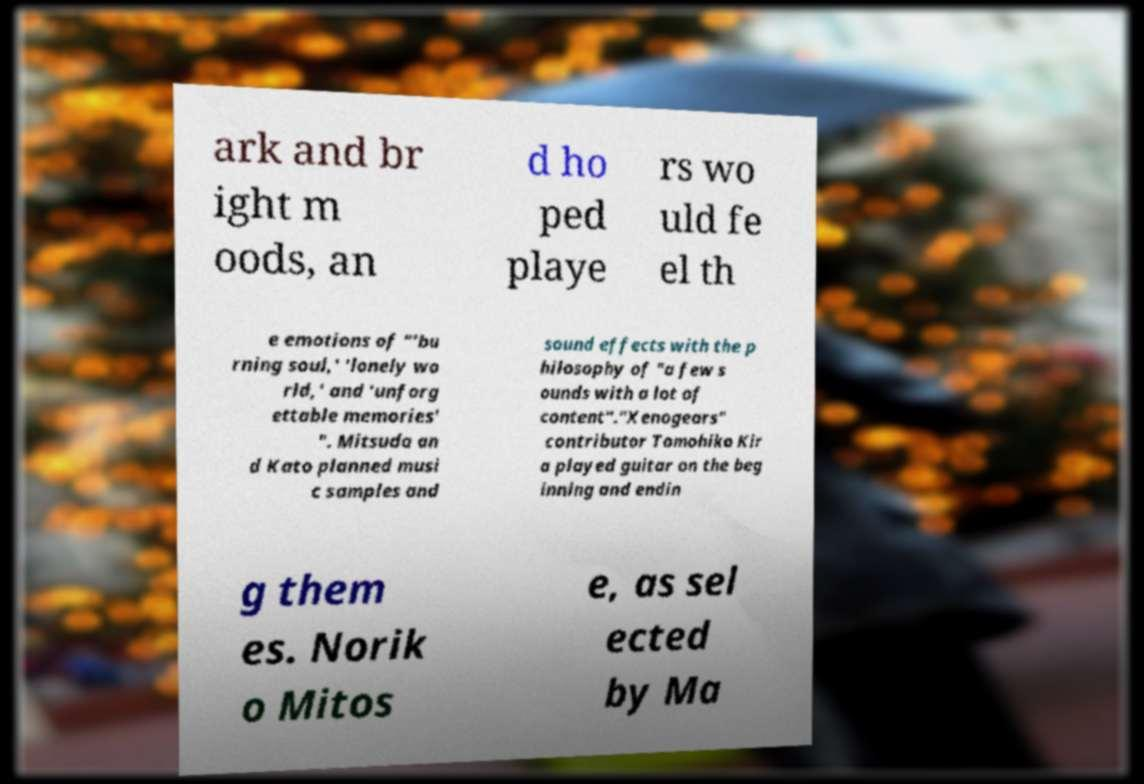For documentation purposes, I need the text within this image transcribed. Could you provide that? ark and br ight m oods, an d ho ped playe rs wo uld fe el th e emotions of "'bu rning soul,' 'lonely wo rld,' and 'unforg ettable memories' ". Mitsuda an d Kato planned musi c samples and sound effects with the p hilosophy of "a few s ounds with a lot of content"."Xenogears" contributor Tomohiko Kir a played guitar on the beg inning and endin g them es. Norik o Mitos e, as sel ected by Ma 